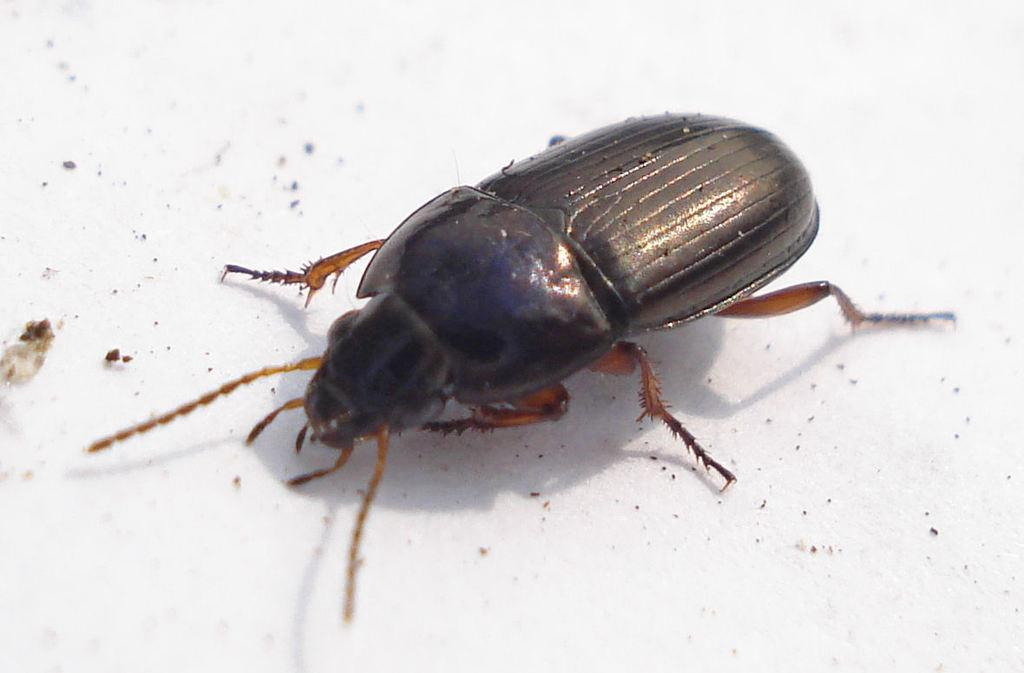What is the main subject of the image? The main subject of the image is a cockroach. Can you describe the surface on which the cockroach is located? The cockroach is on a white surface. What type of pie is being served on the trains in the image? There is no pie or trains present in the image; it features a cockroach on a white surface. 